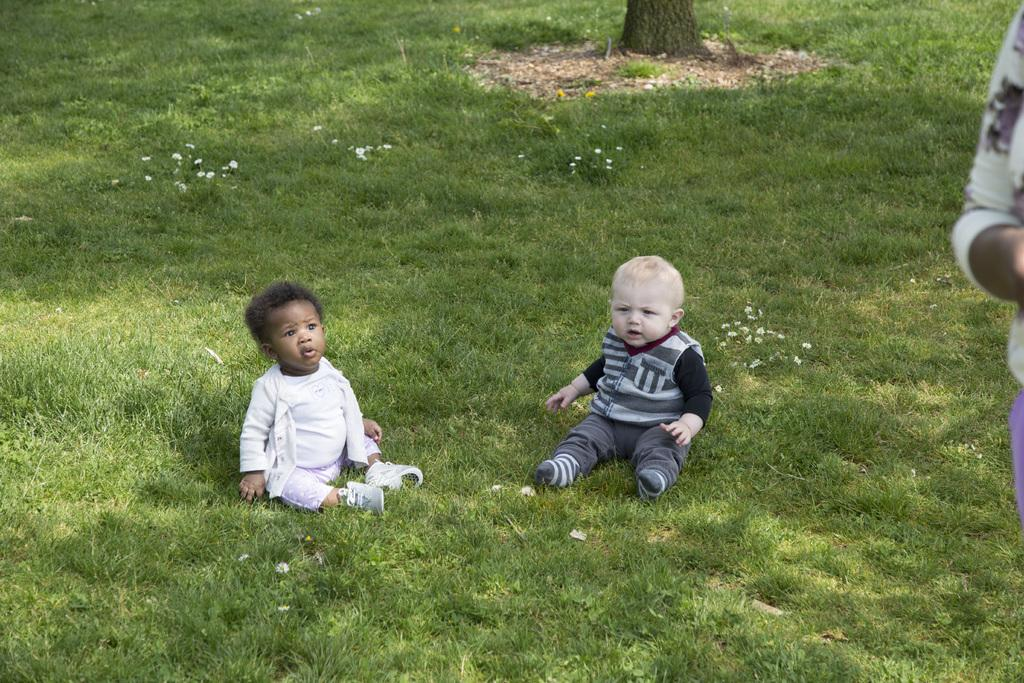How many children are present in the image? There are two children sitting in the image. What can be seen towards the right side of the image? There is a partial body of a human visible towards the right side of the image. What is visible in the background of the image? There is a trunk and grass visible in the background of the image. What is the process of the children playing in the image? The image does not show the children playing, so it is not possible to describe a process. 